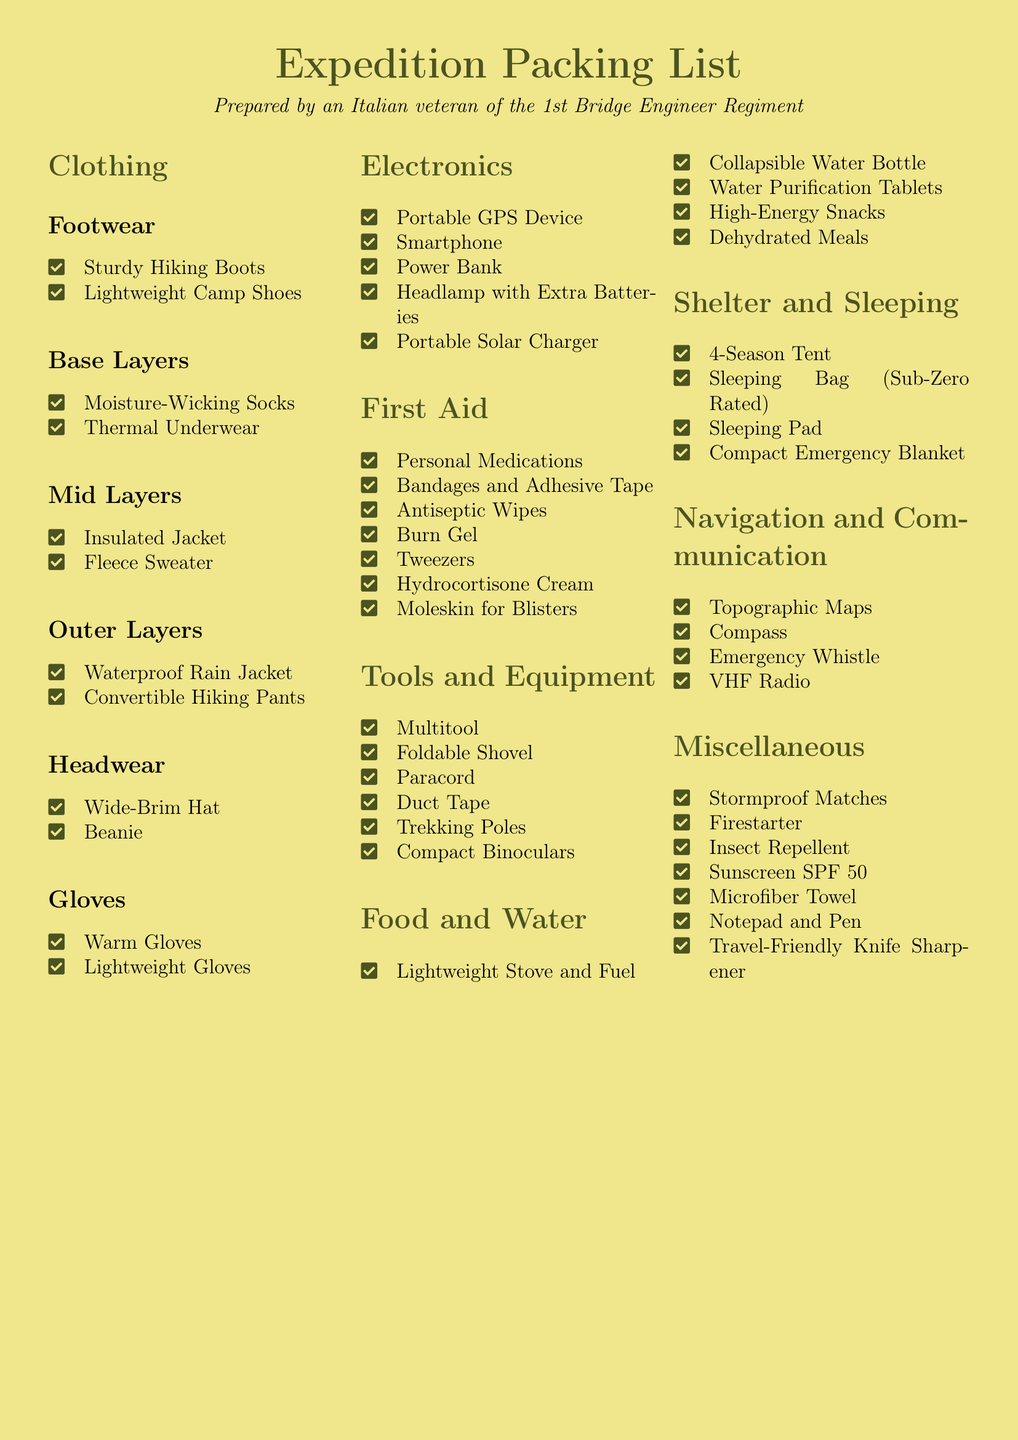What is the primary purpose of this document? The primary purpose of the document is to provide a packing list for a hiking expedition, as indicated in the title.
Answer: Packing list for a hiking expedition How many categories of items are listed in the document? The document features multiple categories, including Clothing, Electronics, First Aid, Tools and Equipment, Food and Water, Shelter and Sleeping, Navigation and Communication, and Miscellaneous, totaling eight categories.
Answer: Eight categories What is an example of a First Aid item mentioned? The document lists several First Aid items, one of which is Antiseptic Wipes.
Answer: Antiseptic Wipes Which item is recommended for Headwear? The Headwear section includes items, one of which is a Wide-Brim Hat.
Answer: Wide-Brim Hat What type of tent is suggested in the Shelter and Sleeping section? It specifies a 4-Season Tent in the Shelter and Sleeping category, indicating the type of tent recommended.
Answer: 4-Season Tent What electronic item is used for navigation? Among the listed electronics, a Portable GPS Device is designated for navigation purposes.
Answer: Portable GPS Device How many items are listed under Tools and Equipment? The Tools and Equipment section has six items listed, which include Multitool, Foldable Shovel, Paracord, Duct Tape, Trekking Poles, and Compact Binoculars.
Answer: Six items Which layer of clothing should be waterproof? The document indicates that the Outer Layer includes a Waterproof Rain Jacket, outlining the need for waterproof clothing.
Answer: Waterproof Rain Jacket What is the capacity referenced for the Sleeping Bag? The packing list specifies a Sleeping Bag that is Sub-Zero Rated, indicating its thermal capacity.
Answer: Sub-Zero Rated 